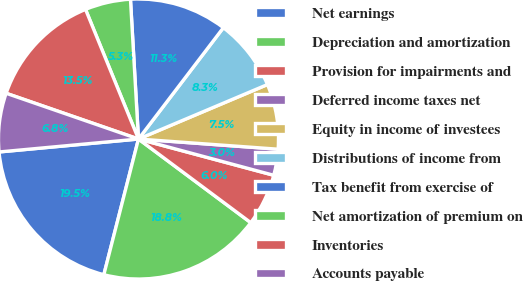<chart> <loc_0><loc_0><loc_500><loc_500><pie_chart><fcel>Net earnings<fcel>Depreciation and amortization<fcel>Provision for impairments and<fcel>Deferred income taxes net<fcel>Equity in income of investees<fcel>Distributions of income from<fcel>Tax benefit from exercise of<fcel>Net amortization of premium on<fcel>Inventories<fcel>Accounts payable<nl><fcel>19.55%<fcel>18.79%<fcel>6.02%<fcel>3.01%<fcel>7.52%<fcel>8.27%<fcel>11.28%<fcel>5.26%<fcel>13.53%<fcel>6.77%<nl></chart> 